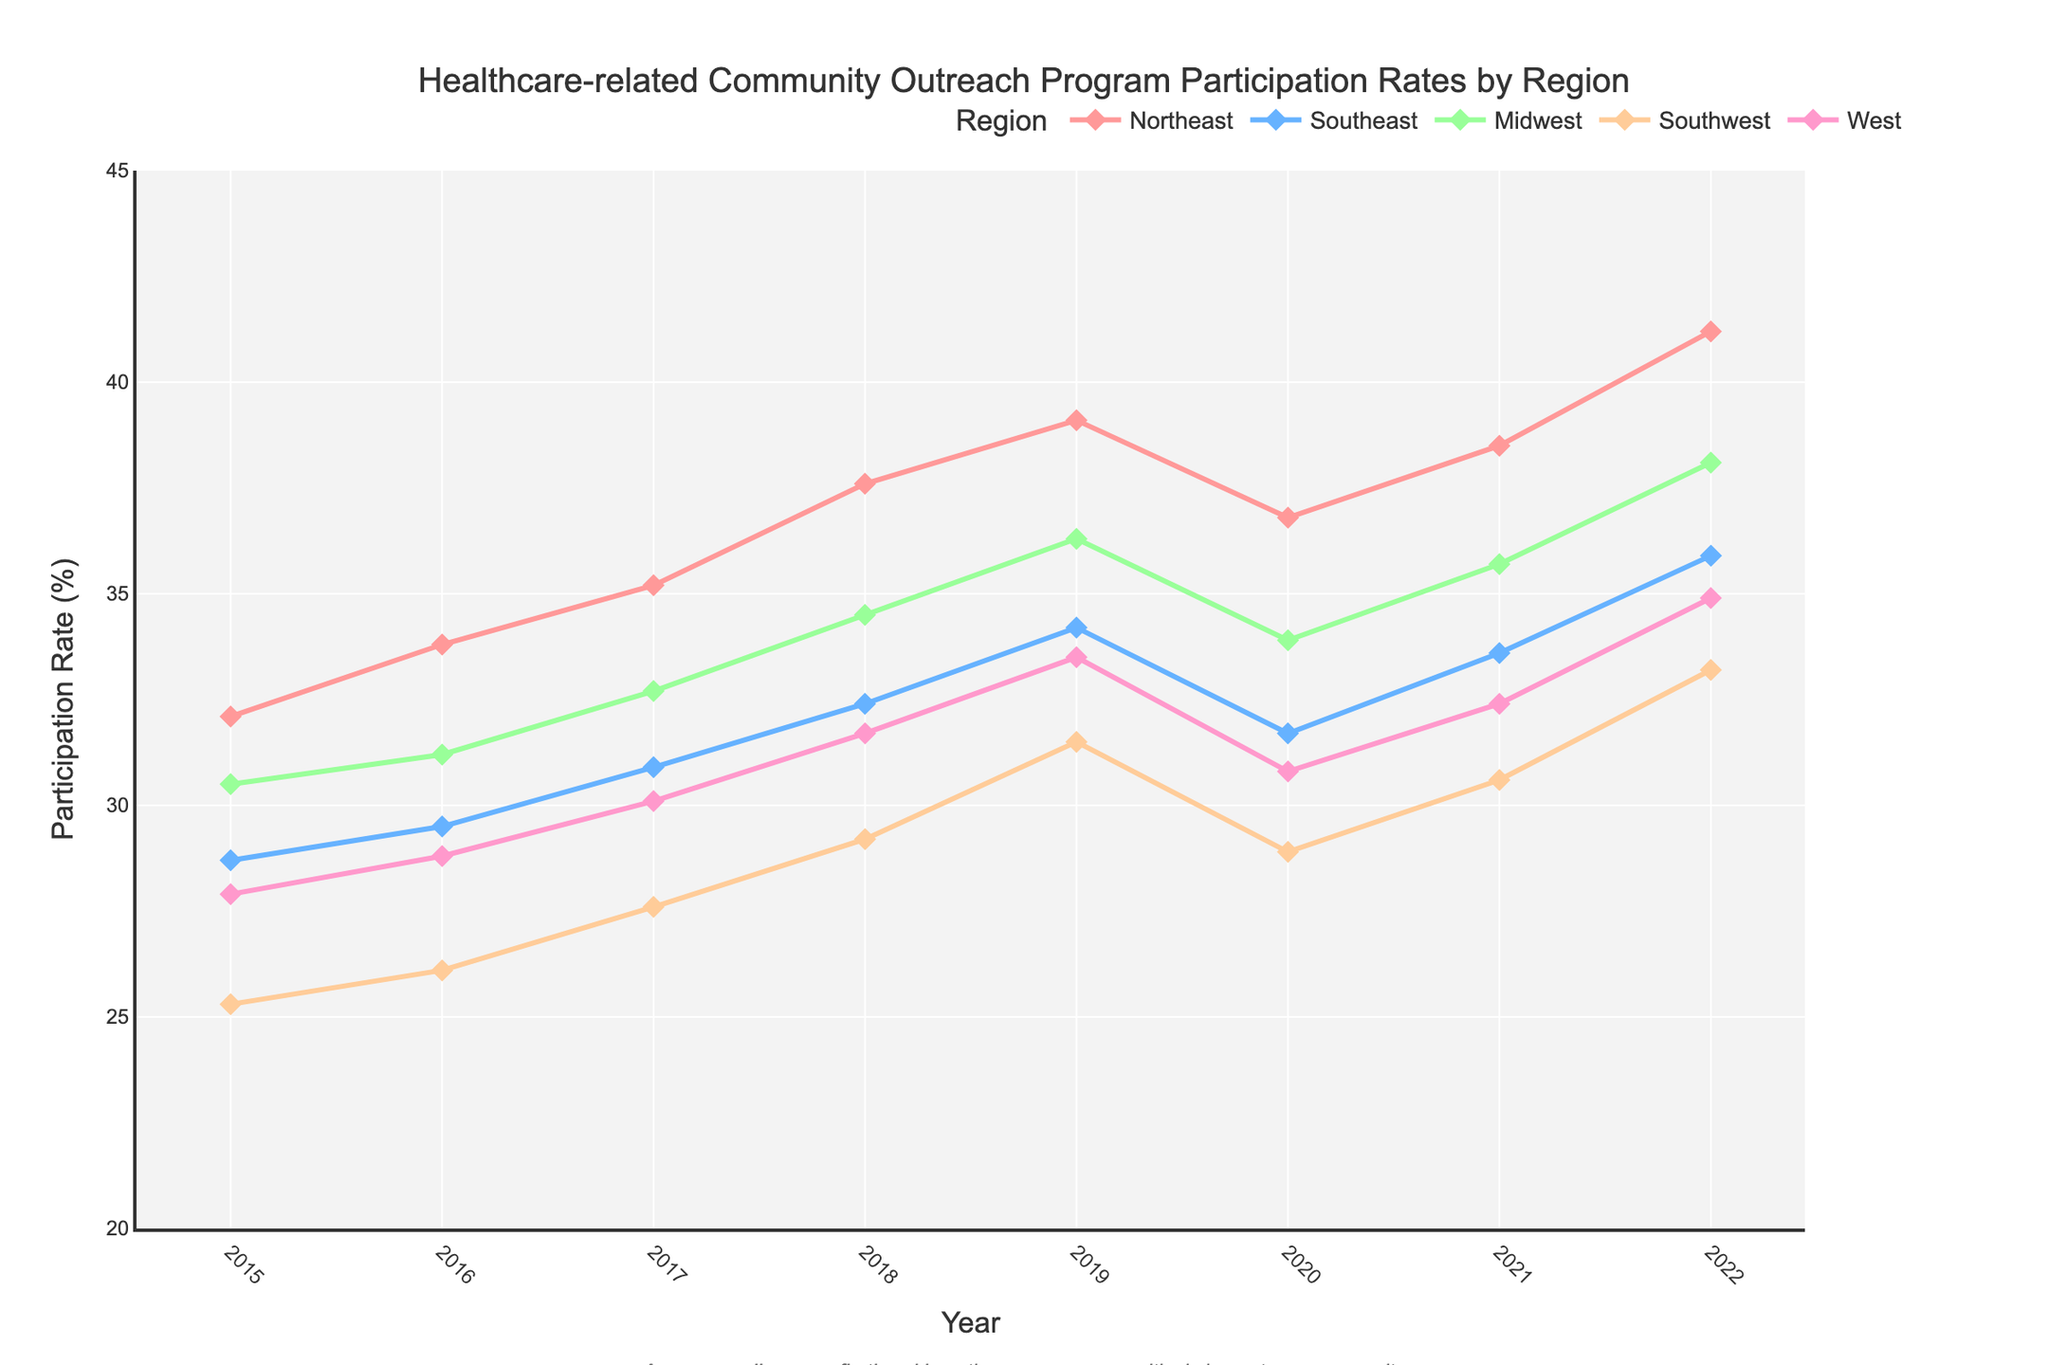Which region had the highest participation rate in 2022? Look at the values for the year 2022. The West had 34.9%, the Southwest had 33.2%, the Midwest had 38.1%, the Southeast had 35.9%, and the Northeast had 41.2%. The Northeast had the highest participation rate.
Answer: Northeast How did the participation rate in the Midwest change from 2015 to 2020? Compare the participation rate values for the Midwest in 2015 and 2020. In 2015, it was 30.5%, and in 2020, it was 33.9%. The difference is 33.9% - 30.5% = 3.4%.
Answer: Increased by 3.4% Between which consecutive years did the Southeast see the largest increase in participation? Compare the differences between consecutive years for the Southeast. The differences are: 2015-2016: 0.8, 2016-2017: 1.4, 2017-2018: 1.5, 2018-2019: 1.8, 2019-2020: -2.5, 2020-2021: 1.9, 2021-2022: 2.3. The largest increase was between 2021 and 2022.
Answer: 2021-2022 What was the average participation rate for the Southwest from 2015 to 2022? Sum the participation rates for the Southwest from 2015 to 2022 and divide by the number of years. (25.3 + 26.1 + 27.6 + 29.2 + 31.5 + 28.9 + 30.6 + 33.2) / 8 = 232.4 / 8 = 29.05.
Answer: 29.05% Which region had the least fluctuation in participation rates over the years? Look at the range (max - min) of participation rates for each region. Calculate: Northeast (41.2 - 32.1 = 9.1), Southeast (35.9 - 28.7 = 7.2), Midwest (38.1 - 30.5 = 7.6), Southwest (33.2 - 25.3 = 7.9), West (34.9 - 27.9 = 7.0). The West had the smallest range.
Answer: West In which year did the West region see the sharpest increase in participation rate? Calculate the year-over-year changes for the West region. Differences are 2015-2016: 0.9, 2016-2017: 1.3, 2017-2018: 1.6, 2018-2019: 1.8, 2019-2020: -2.7, 2020-2021: 1.6, 2021-2022: 2.5. The sharpest increase was from 2021 to 2022 (2.5).
Answer: 2021-2022 By how many percentage points did the participation rate in the Southeast decline from 2019 to 2020? Compare the participation rate values for the Southeast in 2019 and 2020. In 2019, it was 34.2% and in 2020 it was 31.7%. The difference is 34.2% - 31.7% = 2.5%.
Answer: 2.5 percentage points How do the 2022 participation rates for the Midwest and West compare? Look at the values for 2022. The Midwest had a participation rate of 38.1% and the West had 34.9%. The Midwest's rate is higher.
Answer: Midwest is higher What was the overall trend in participation rates for the Northeast from 2015 to 2022? Observe the values for the Northeast from 2015 to 2022. The values are largely increasing: 32.1, 33.8, 35.2, 37.6, 39.1, 36.8, 38.5, and 41.2. There is a small dip in 2020, but the overall trend is an increase.
Answer: Increasing Which year showed the highest overall participation rate across all regions? Sum the participation rates for all regions for each year and find the highest sum. The sums are: 2015: 144.5, 2016: 149.4, 2017: 156.5, 2018: 165.4, 2019: 174.6, 2020: 162.1, 2021: 170.8, 2022: 183.3. The highest sum is in 2022.
Answer: 2022 